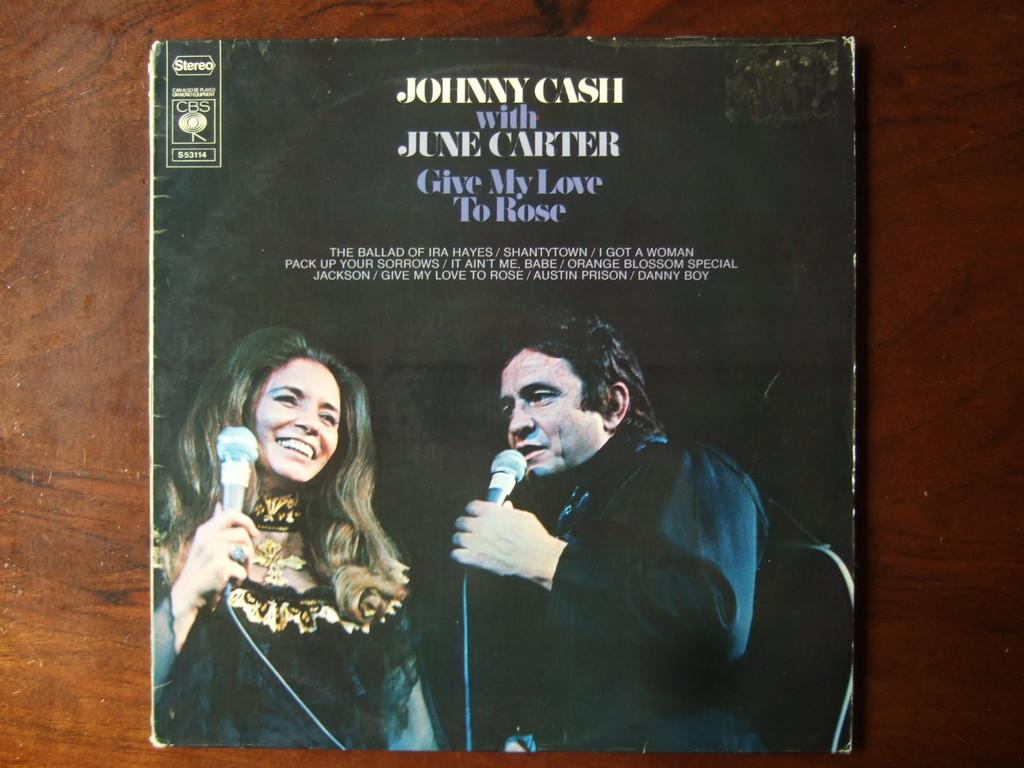Provide a one-sentence caption for the provided image. The cover of the album Give my love to rose by johnny cash and june carter. 